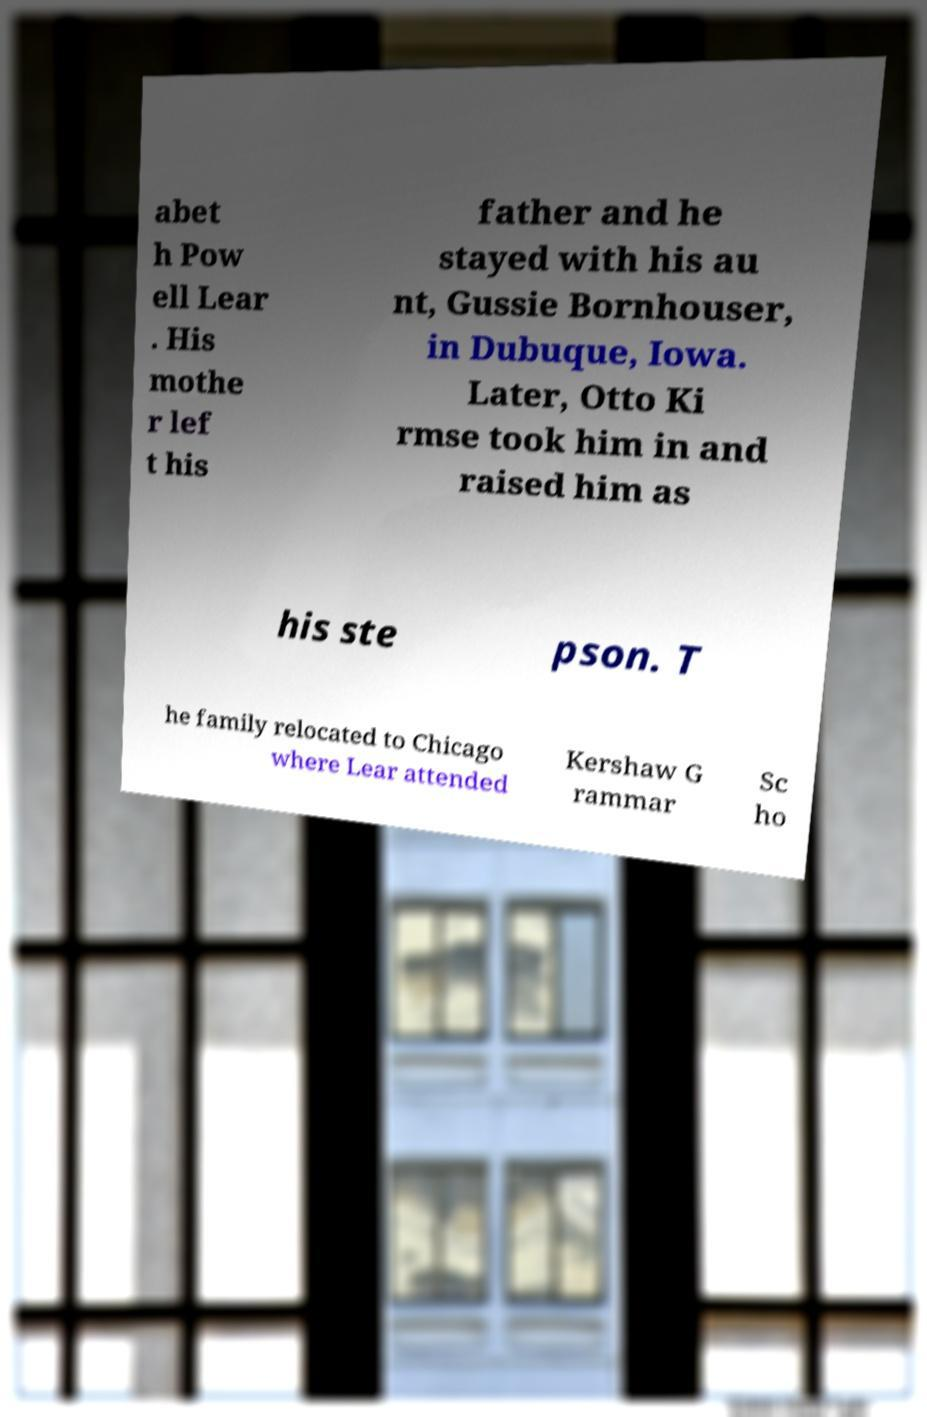Could you assist in decoding the text presented in this image and type it out clearly? abet h Pow ell Lear . His mothe r lef t his father and he stayed with his au nt, Gussie Bornhouser, in Dubuque, Iowa. Later, Otto Ki rmse took him in and raised him as his ste pson. T he family relocated to Chicago where Lear attended Kershaw G rammar Sc ho 